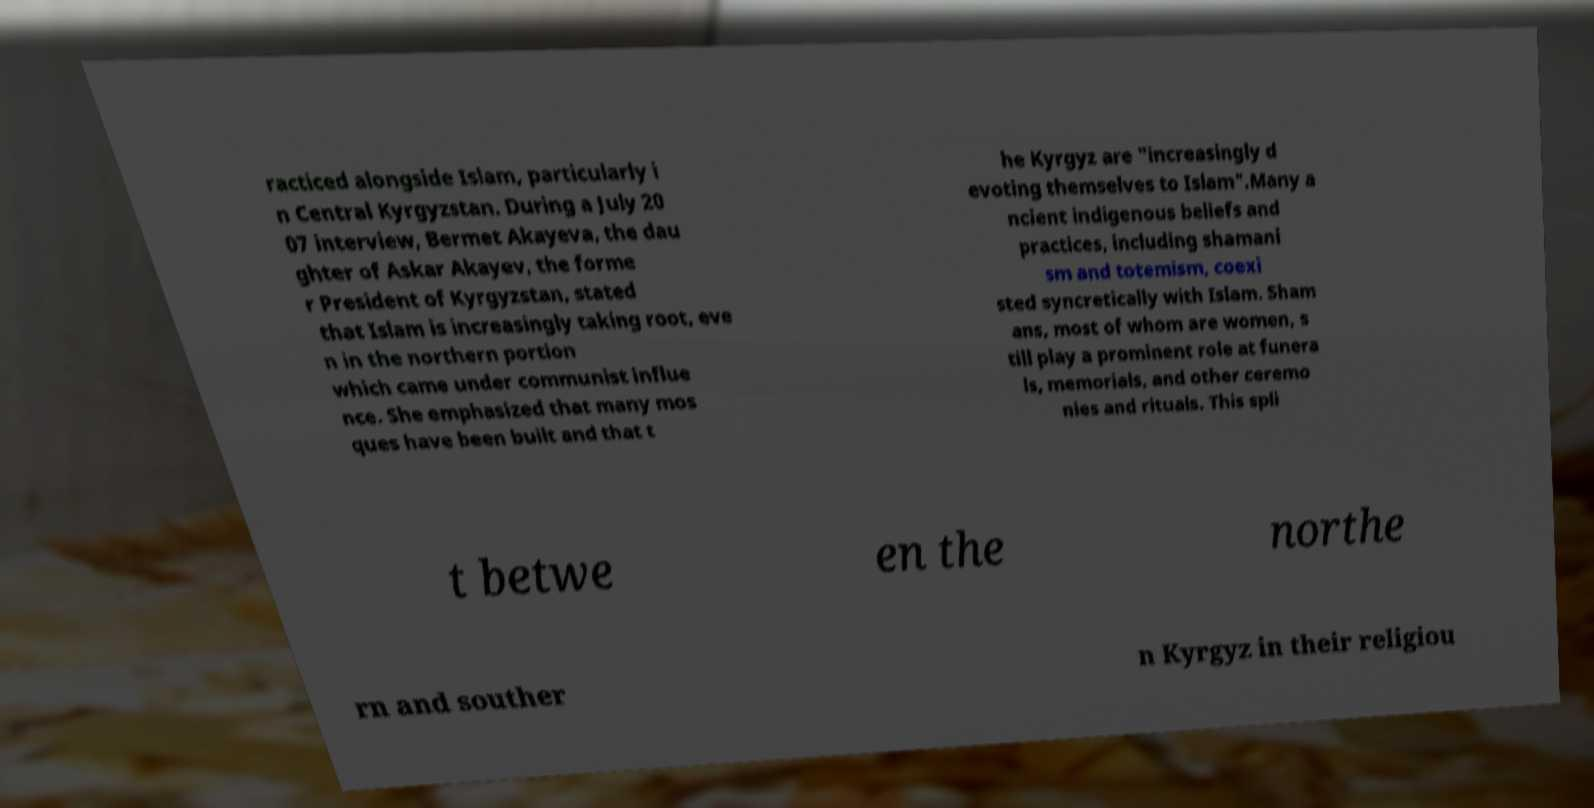What messages or text are displayed in this image? I need them in a readable, typed format. racticed alongside Islam, particularly i n Central Kyrgyzstan. During a July 20 07 interview, Bermet Akayeva, the dau ghter of Askar Akayev, the forme r President of Kyrgyzstan, stated that Islam is increasingly taking root, eve n in the northern portion which came under communist influe nce. She emphasized that many mos ques have been built and that t he Kyrgyz are "increasingly d evoting themselves to Islam".Many a ncient indigenous beliefs and practices, including shamani sm and totemism, coexi sted syncretically with Islam. Sham ans, most of whom are women, s till play a prominent role at funera ls, memorials, and other ceremo nies and rituals. This spli t betwe en the northe rn and souther n Kyrgyz in their religiou 